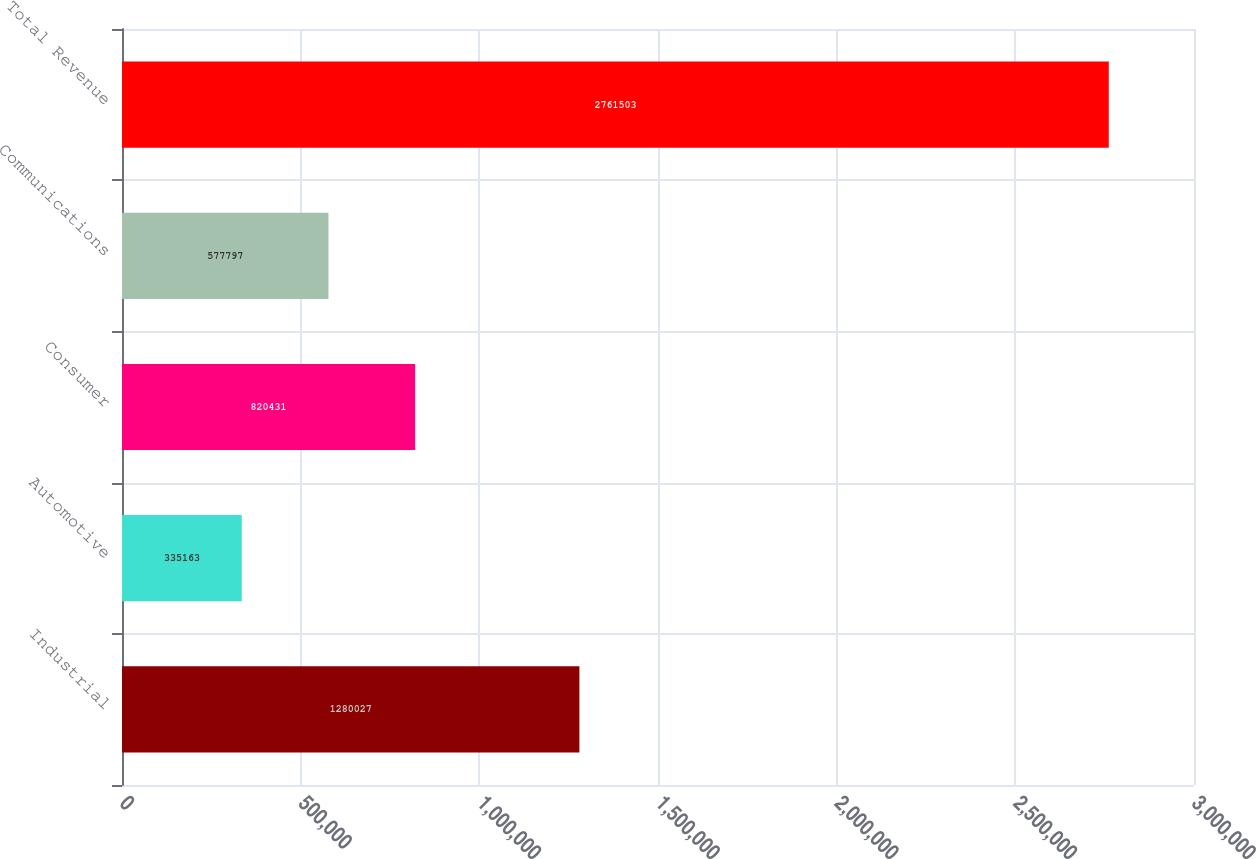<chart> <loc_0><loc_0><loc_500><loc_500><bar_chart><fcel>Industrial<fcel>Automotive<fcel>Consumer<fcel>Communications<fcel>Total Revenue<nl><fcel>1.28003e+06<fcel>335163<fcel>820431<fcel>577797<fcel>2.7615e+06<nl></chart> 